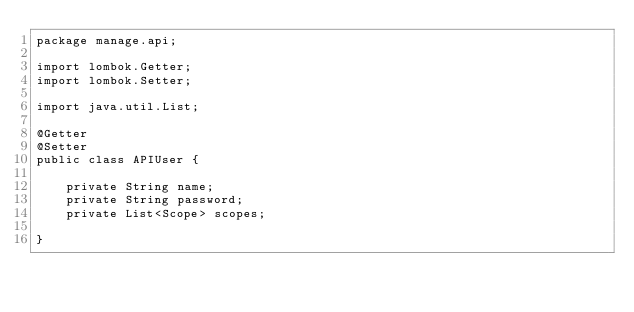Convert code to text. <code><loc_0><loc_0><loc_500><loc_500><_Java_>package manage.api;

import lombok.Getter;
import lombok.Setter;

import java.util.List;

@Getter
@Setter
public class APIUser {

    private String name;
    private String password;
    private List<Scope> scopes;

}
</code> 